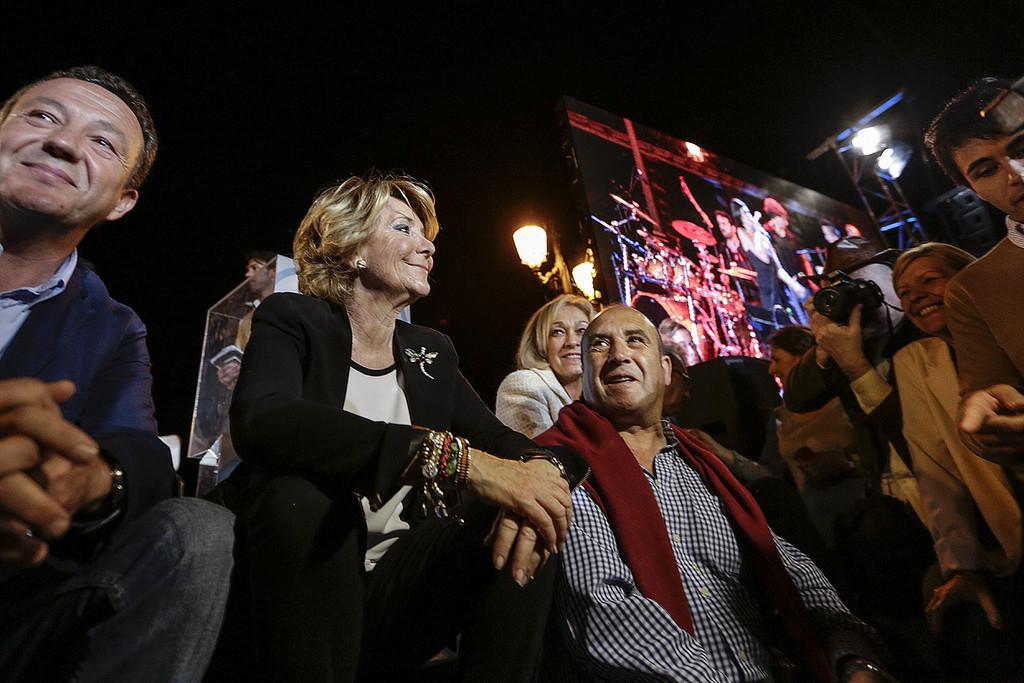Could you give a brief overview of what you see in this image? In this image there are group of people who are sitting and laughing. On the right side there is a man who is taking the pictures with the camera. In the background there is a screen. Behind the screen there is a light. 